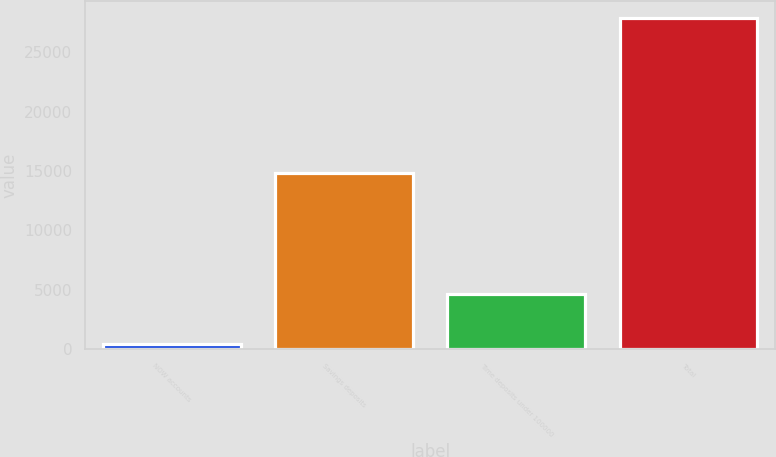Convert chart. <chart><loc_0><loc_0><loc_500><loc_500><bar_chart><fcel>NOW accounts<fcel>Savings deposits<fcel>Time deposits under 100000<fcel>Total<nl><fcel>400<fcel>14827<fcel>4624<fcel>27901<nl></chart> 